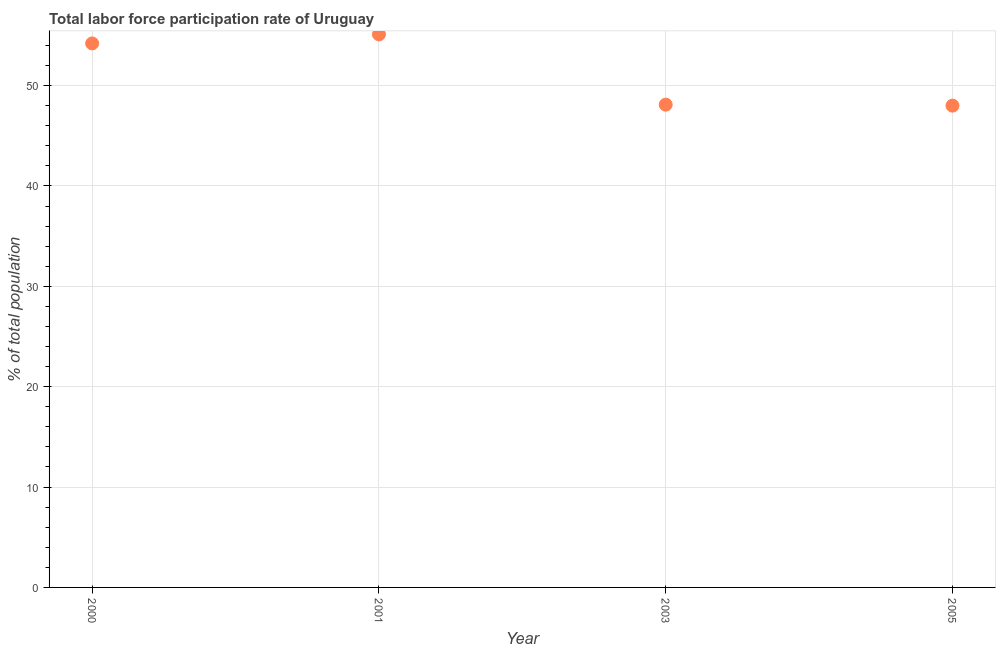What is the total labor force participation rate in 2001?
Make the answer very short. 55.1. Across all years, what is the maximum total labor force participation rate?
Your answer should be compact. 55.1. Across all years, what is the minimum total labor force participation rate?
Ensure brevity in your answer.  48. In which year was the total labor force participation rate maximum?
Your response must be concise. 2001. What is the sum of the total labor force participation rate?
Offer a terse response. 205.4. What is the difference between the total labor force participation rate in 2000 and 2005?
Offer a terse response. 6.2. What is the average total labor force participation rate per year?
Your answer should be compact. 51.35. What is the median total labor force participation rate?
Offer a terse response. 51.15. In how many years, is the total labor force participation rate greater than 14 %?
Offer a terse response. 4. What is the ratio of the total labor force participation rate in 2000 to that in 2001?
Your answer should be compact. 0.98. Is the difference between the total labor force participation rate in 2000 and 2001 greater than the difference between any two years?
Provide a succinct answer. No. What is the difference between the highest and the second highest total labor force participation rate?
Your answer should be very brief. 0.9. Is the sum of the total labor force participation rate in 2003 and 2005 greater than the maximum total labor force participation rate across all years?
Your answer should be compact. Yes. What is the difference between the highest and the lowest total labor force participation rate?
Provide a succinct answer. 7.1. In how many years, is the total labor force participation rate greater than the average total labor force participation rate taken over all years?
Your answer should be compact. 2. Does the total labor force participation rate monotonically increase over the years?
Provide a succinct answer. No. How many dotlines are there?
Provide a succinct answer. 1. What is the difference between two consecutive major ticks on the Y-axis?
Give a very brief answer. 10. Are the values on the major ticks of Y-axis written in scientific E-notation?
Provide a short and direct response. No. Does the graph contain any zero values?
Your answer should be compact. No. What is the title of the graph?
Provide a succinct answer. Total labor force participation rate of Uruguay. What is the label or title of the X-axis?
Make the answer very short. Year. What is the label or title of the Y-axis?
Give a very brief answer. % of total population. What is the % of total population in 2000?
Keep it short and to the point. 54.2. What is the % of total population in 2001?
Offer a very short reply. 55.1. What is the % of total population in 2003?
Keep it short and to the point. 48.1. What is the difference between the % of total population in 2000 and 2003?
Offer a terse response. 6.1. What is the difference between the % of total population in 2001 and 2005?
Your response must be concise. 7.1. What is the difference between the % of total population in 2003 and 2005?
Offer a very short reply. 0.1. What is the ratio of the % of total population in 2000 to that in 2001?
Your answer should be compact. 0.98. What is the ratio of the % of total population in 2000 to that in 2003?
Make the answer very short. 1.13. What is the ratio of the % of total population in 2000 to that in 2005?
Give a very brief answer. 1.13. What is the ratio of the % of total population in 2001 to that in 2003?
Offer a very short reply. 1.15. What is the ratio of the % of total population in 2001 to that in 2005?
Provide a succinct answer. 1.15. 